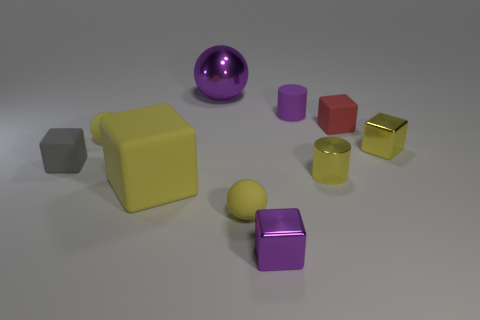There is a yellow cylinder that is the same material as the small purple cube; what is its size?
Provide a short and direct response. Small. Is there anything else that is the same color as the large ball?
Provide a short and direct response. Yes. What material is the tiny cylinder in front of the yellow shiny object behind the cylinder in front of the small red object?
Your answer should be compact. Metal. How many matte objects are small purple blocks or purple spheres?
Provide a short and direct response. 0. Do the small metallic cylinder and the big matte thing have the same color?
Ensure brevity in your answer.  Yes. Is there any other thing that is the same material as the red block?
Keep it short and to the point. Yes. What number of objects are small yellow matte spheres or tiny matte things right of the purple cube?
Provide a short and direct response. 4. There is a purple shiny object that is behind the red block; is its size the same as the tiny yellow metal cube?
Provide a succinct answer. No. What number of other things are there of the same shape as the big purple shiny object?
Provide a succinct answer. 2. What number of cyan things are rubber objects or shiny things?
Ensure brevity in your answer.  0. 